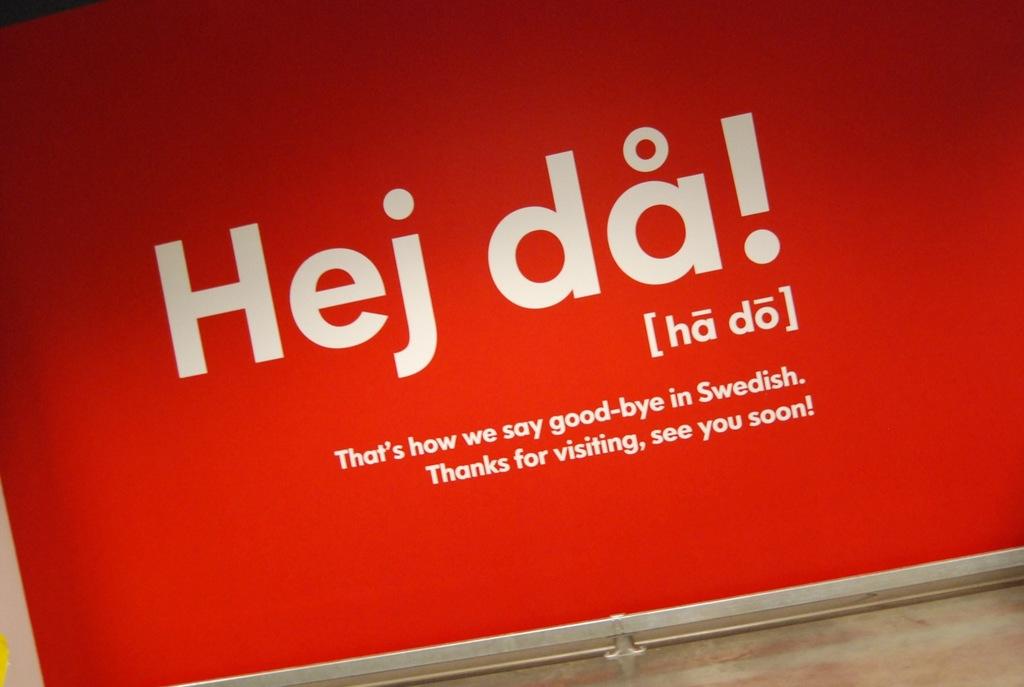What does this say, in swedish?
Your response must be concise. Good-bye. What does the bottom of the art thank you for?
Provide a short and direct response. Visiting. 